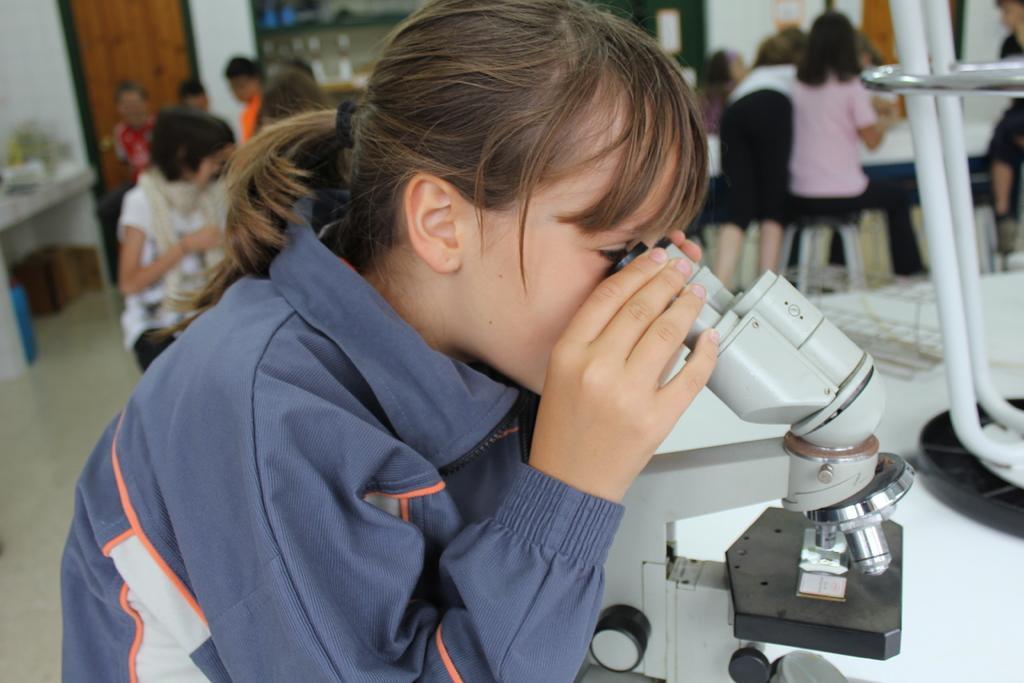In one or two sentences, can you explain what this image depicts? In this image we can see many people. There is a microscope in the image. There are many objects on the table at the left side of the image. There is an object on the ground at the left side of the image. There are few objects placed on the table at the right side of the image. 